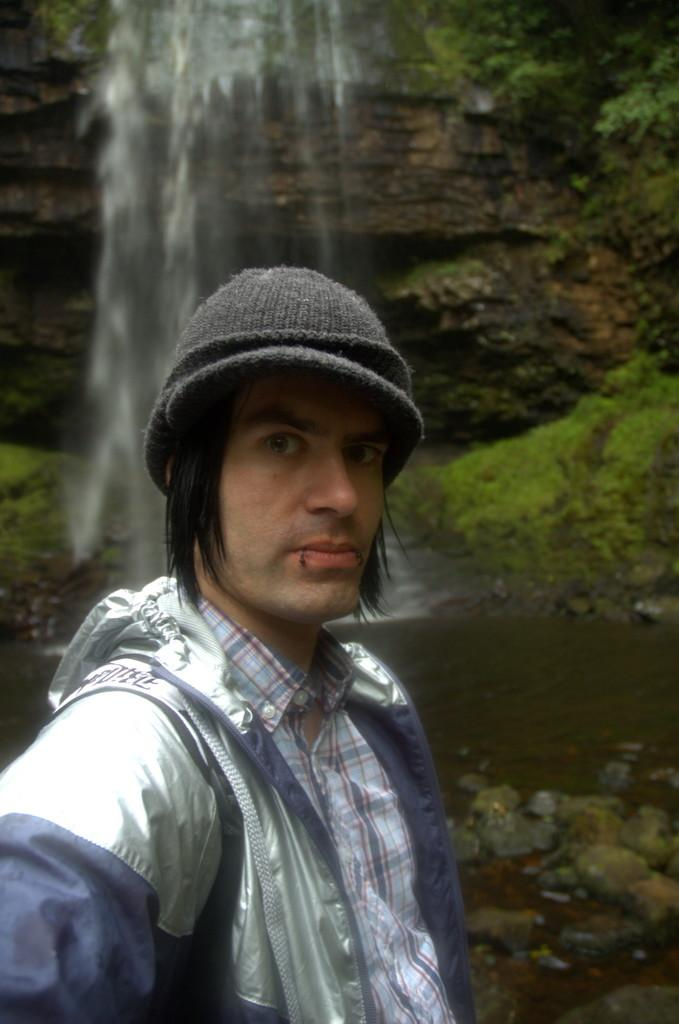What is the main subject of the image? There is a man standing in the image. What is the man wearing in the image? The man is wearing a jacket and a cap. Where is the man located in the image? The man is at the bottom of the image. What can be seen in the background of the image? There is a waterfall in the background of the image. What is the tendency of the play in the image? There is no play present in the image, so it's not possible to determine its tendency. 